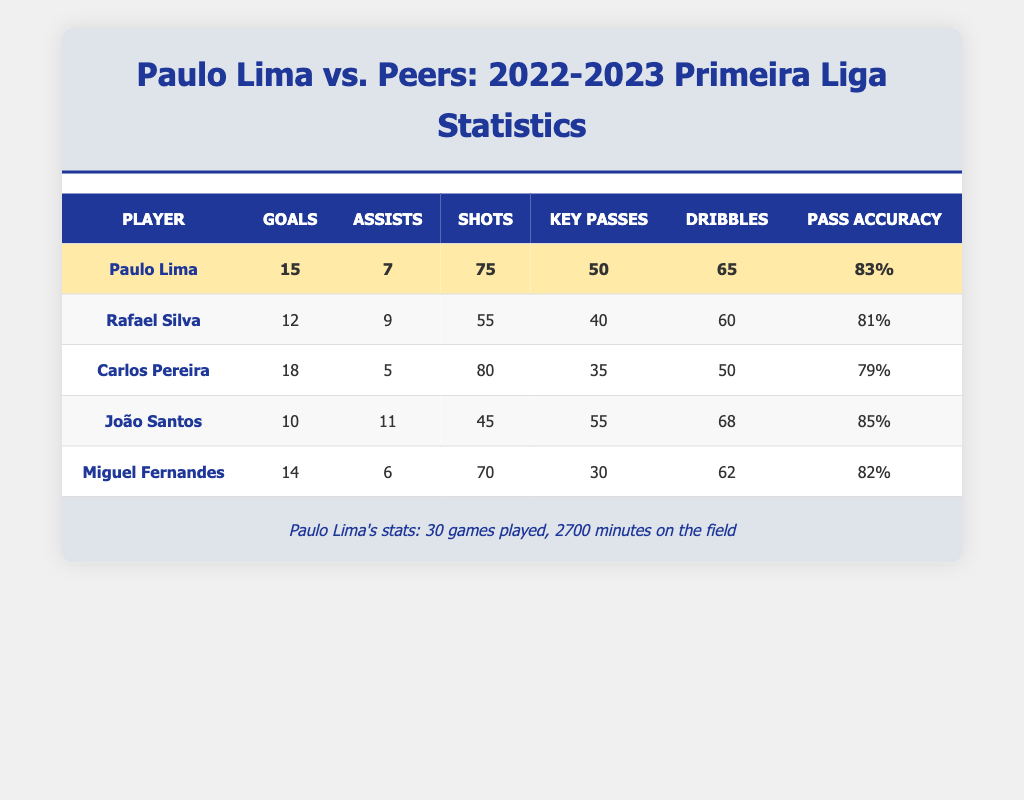What is Paulo Lima's total number of assists? From the table, Paulo Lima has made 7 assists during the 2022-2023 season.
Answer: 7 Who has the highest goals scored among the players listed? Carlos Pereira has the highest goals scored with 18 goals, which is more than Paulo Lima's 15 and others in the list.
Answer: Carlos Pereira How many more shots did Paulo Lima take compared to João Santos? Paulo Lima took 75 shots, while João Santos took 45 shots. The difference is 75 - 45 = 30 more shots for Paulo Lima.
Answer: 30 Is it true that Miguel Fernandes has a higher pass accuracy than Paulo Lima? No, Miguel Fernandes has a pass accuracy of 82%, which is lower than Paulo Lima's 83%.
Answer: No What is the average number of goals scored by the peers in the table? The total goals scored by peers are (12 + 18 + 10 + 14) = 54. There are 4 peers, so the average is 54 / 4 = 13.5.
Answer: 13.5 How many assists did Rafael Silva and Miguel Fernandes combine for? Rafael Silva has 9 assists and Miguel Fernandes has 6 assists. Adding these gives 9 + 6 = 15 combined assists.
Answer: 15 Is João Santos the player with the most key passes? Yes, João Santos has the most key passes with a total of 55, more than others in the list.
Answer: Yes What percentage of Paulo Lima's shots resulted in goals? Paulo Lima scored 15 goals from his 75 shots. To find the percentage, divide 15 by 75 and multiply by 100: (15 / 75) * 100 = 20%.
Answer: 20% What is the combined number of dribbles by Carlos Pereira and Rafael Silva? Carlos Pereira has 50 dribbles and Rafael Silva has 60. Adding these gives 50 + 60 = 110 total dribbles.
Answer: 110 